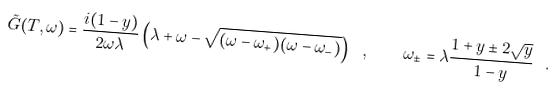<formula> <loc_0><loc_0><loc_500><loc_500>\tilde { G } ( T , \omega ) = \frac { i ( 1 - y ) } { 2 \omega \lambda } \left ( \lambda + \omega - \sqrt { ( \omega - \omega _ { + } ) ( \omega - \omega _ { - } ) } \right ) \ , \quad \omega _ { \pm } = \lambda \frac { 1 + y \pm 2 \sqrt { y } } { 1 - y } \ .</formula> 